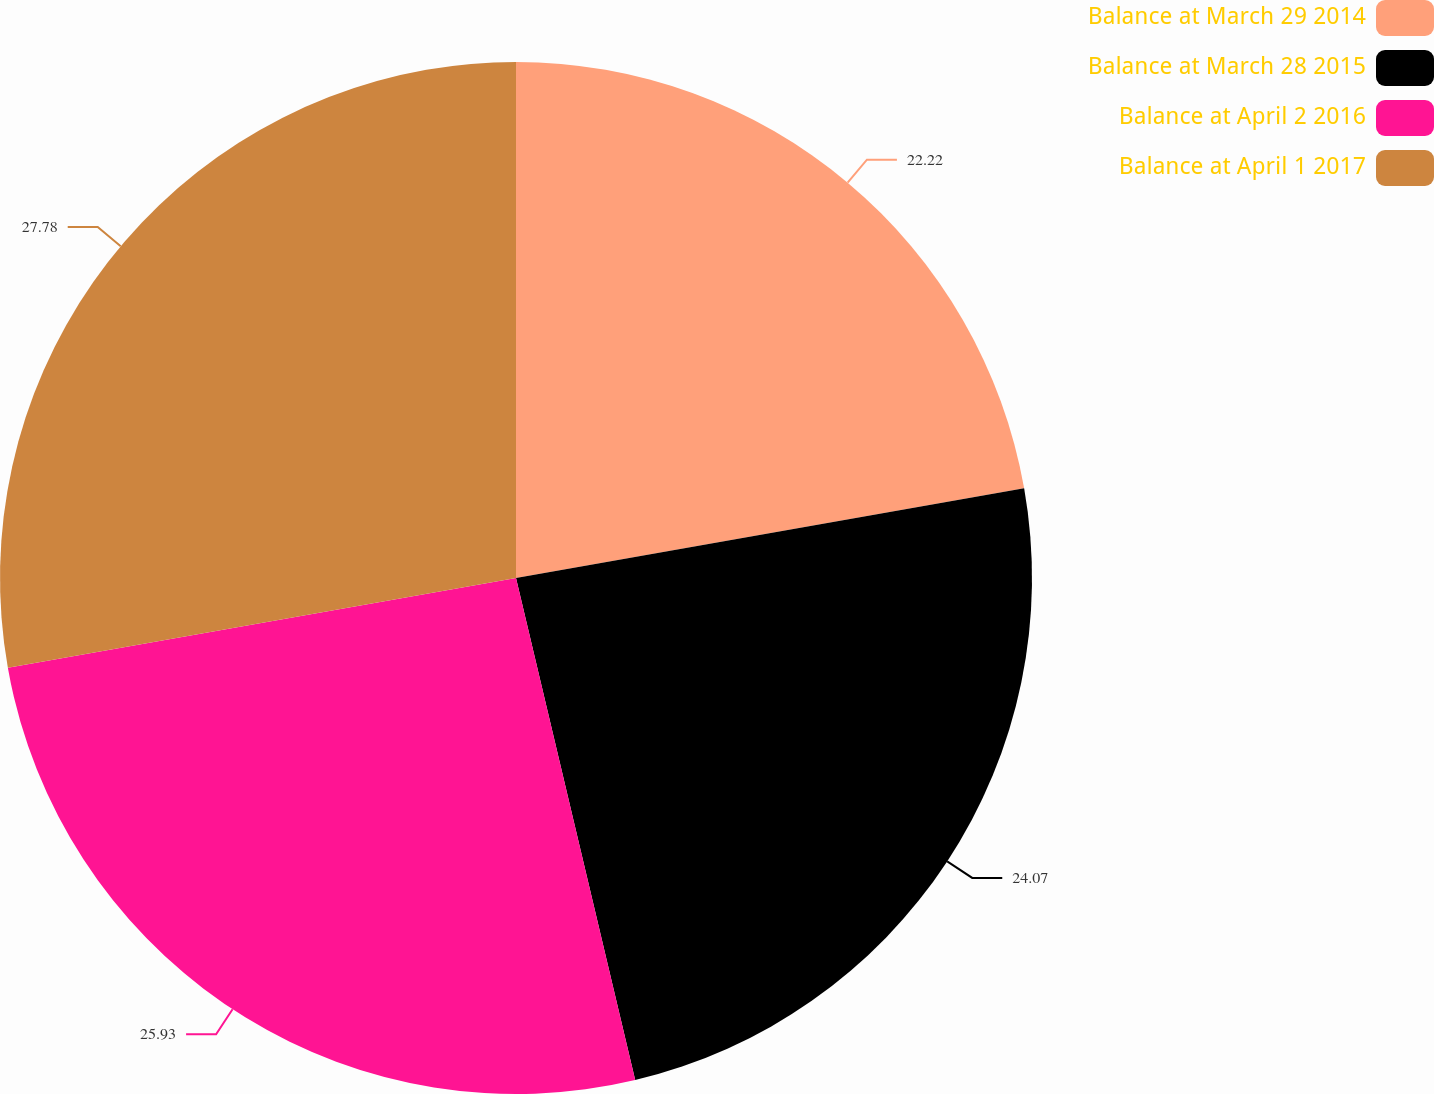Convert chart. <chart><loc_0><loc_0><loc_500><loc_500><pie_chart><fcel>Balance at March 29 2014<fcel>Balance at March 28 2015<fcel>Balance at April 2 2016<fcel>Balance at April 1 2017<nl><fcel>22.22%<fcel>24.07%<fcel>25.93%<fcel>27.78%<nl></chart> 